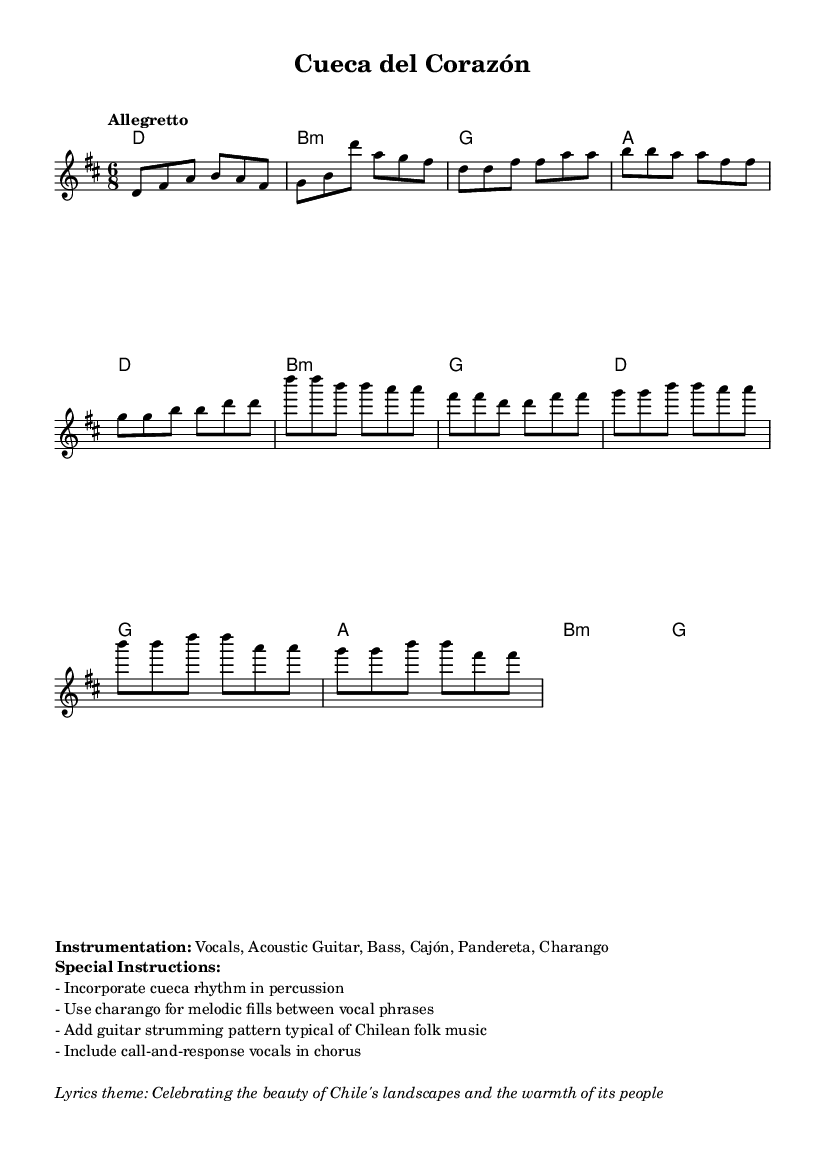What is the key signature of this music? The key signature is indicated at the beginning of the sheet music and shows two sharps, which corresponds to the key of D major.
Answer: D major What is the time signature of this music? The time signature is found at the beginning of the score, displaying a 6 over 8, indicating a compound time signature with each measure containing six eighth notes.
Answer: 6/8 What is the tempo marking for the piece? The tempo marking is included in the header section and indicates "Allegretto," which defines the speed of the music as moderately fast.
Answer: Allegretto How many unique sections are indicated in the piece? Analyzing the structure, the piece is divided into an intro, verse, chorus, and bridge; thus, there are four unique sections.
Answer: Four What instrumentation is specified for the music? Instrumentation details are provided in the markup section, listing the specific instruments: Vocals, Acoustic Guitar, Bass, Cajón, Pandereta, Charango.
Answer: Vocals, Acoustic Guitar, Bass, Cajón, Pandereta, Charango What rhythm style is suggested for the percussion? The special instructions mention the incorporation of a cueca rhythm, which is a traditional Chilean style, specifically for the percussion part.
Answer: Cueca rhythm What thematic element is highlighted in the lyrics? The markup section elaborates on the lyrics theme, emphasizing that it celebrates the beauty of Chile's landscapes and the warmth of its people.
Answer: Celebrating the beauty of Chile's landscapes and the warmth of its people 